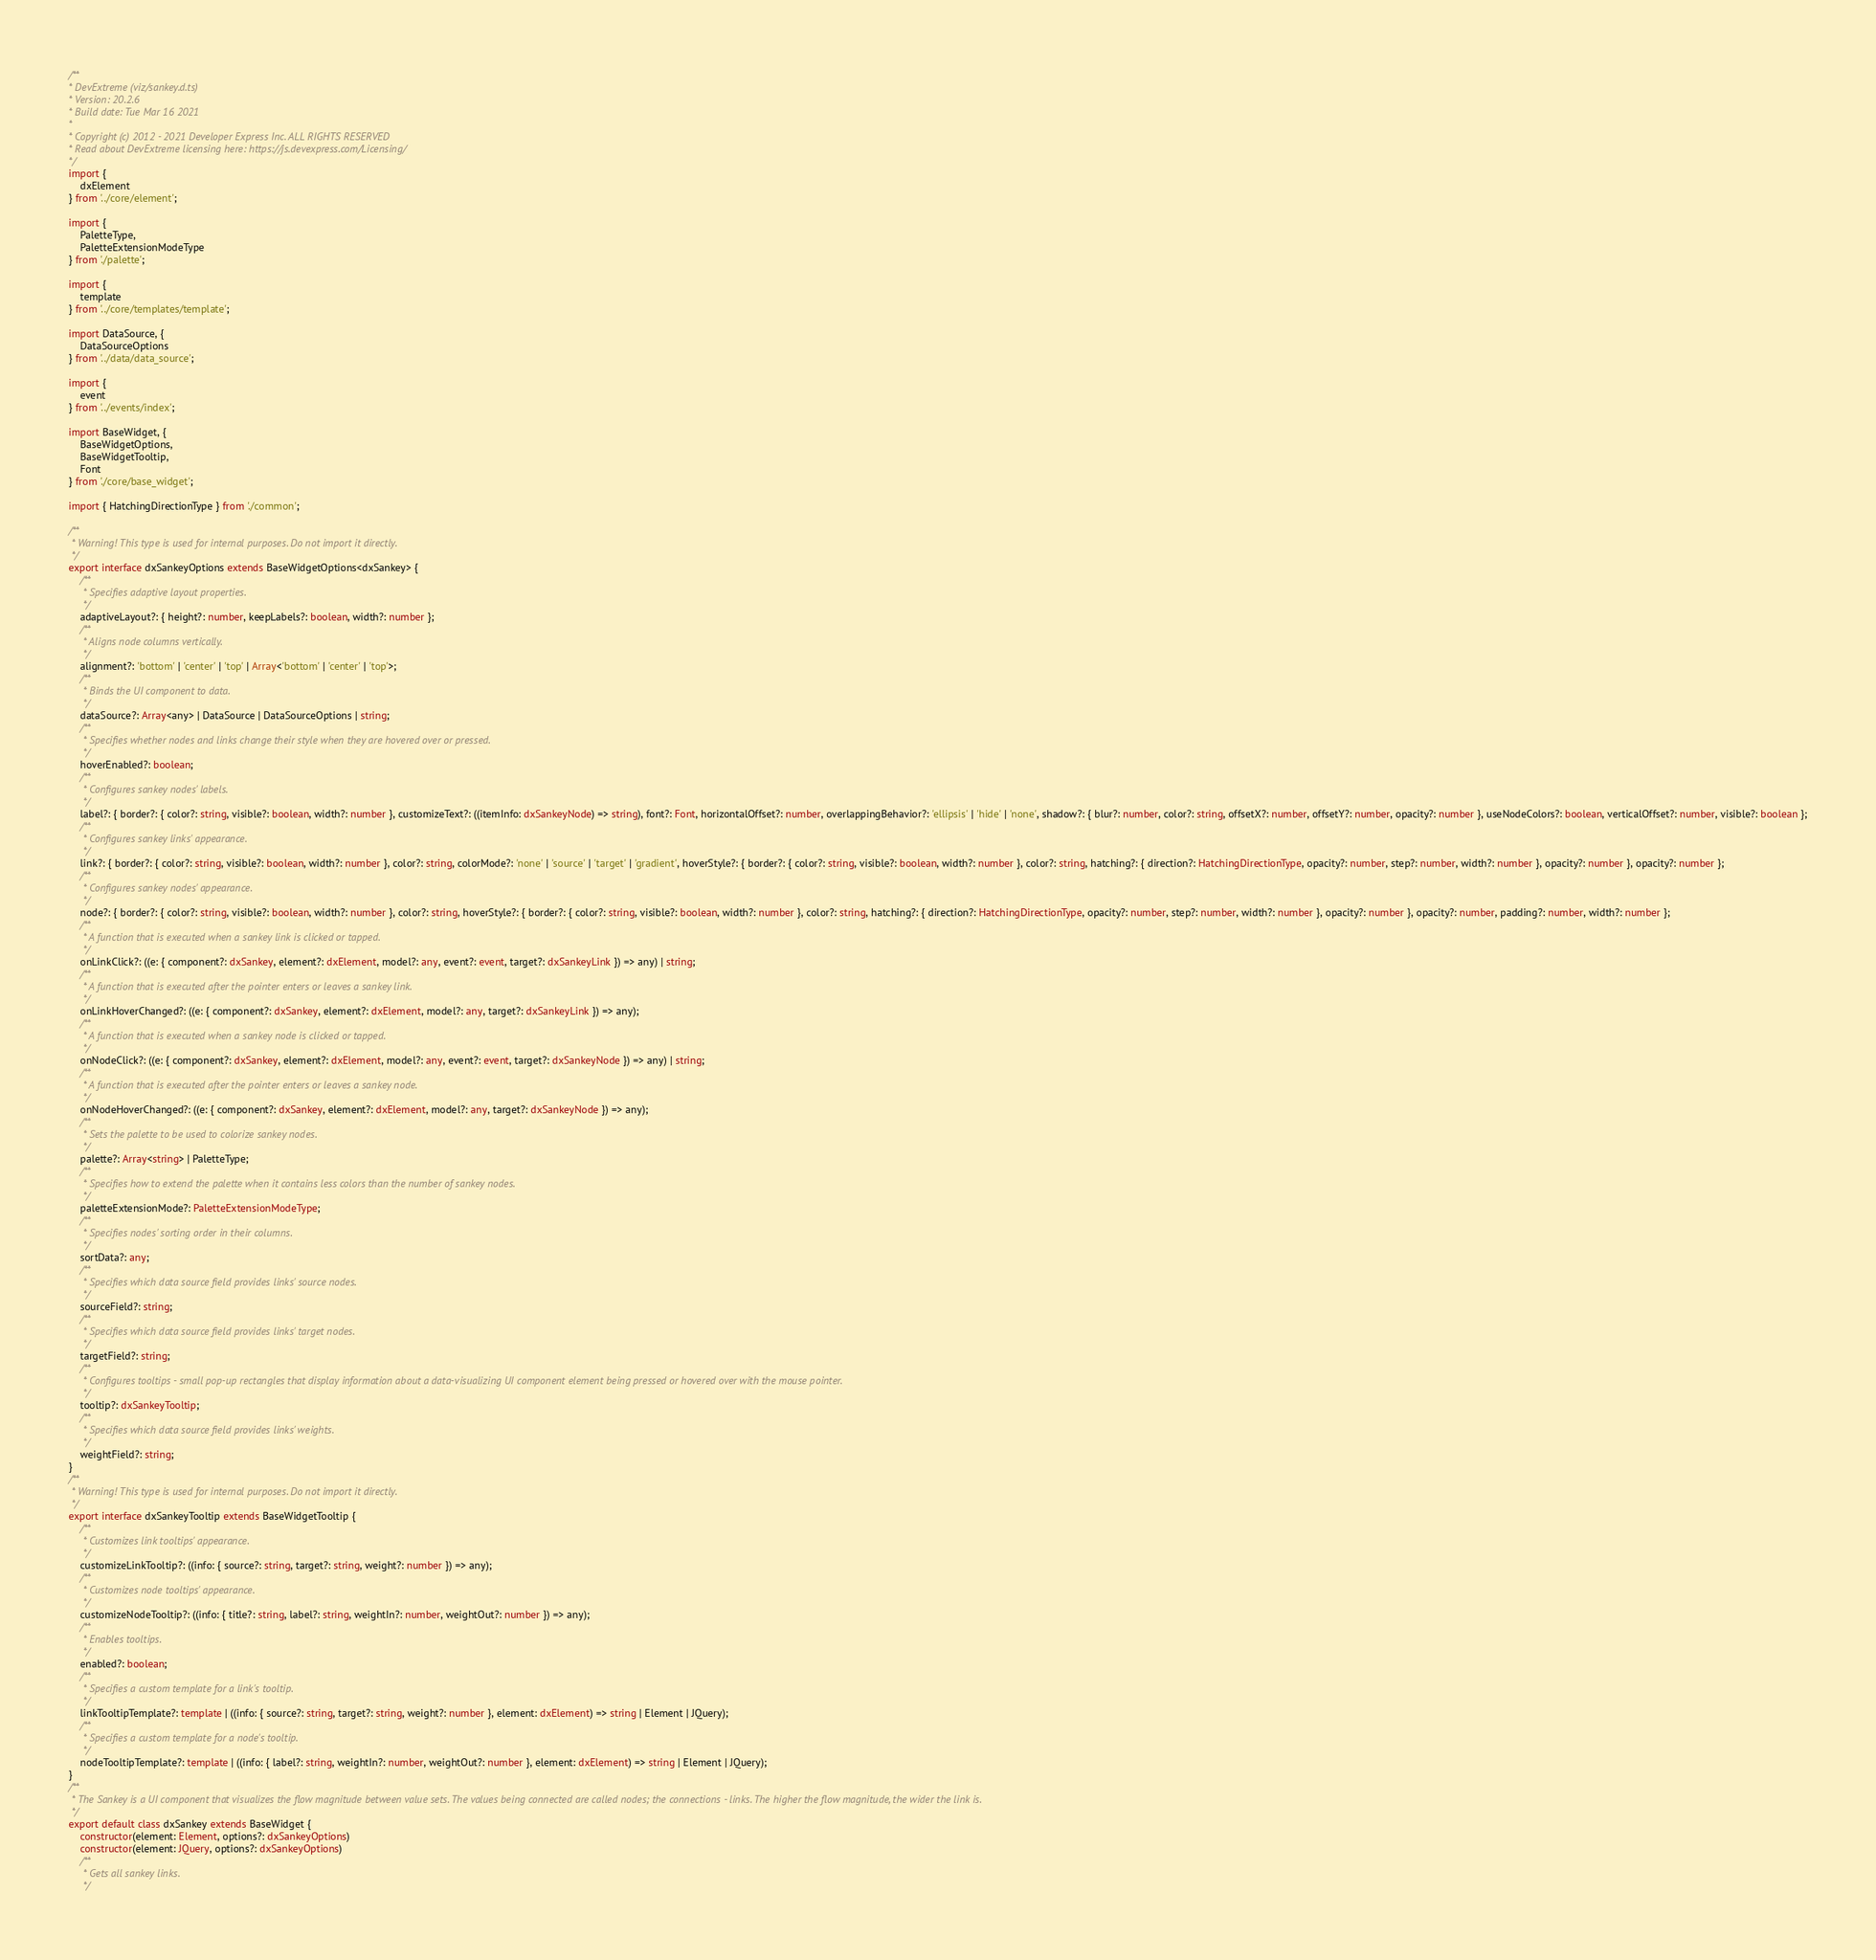Convert code to text. <code><loc_0><loc_0><loc_500><loc_500><_TypeScript_>/**
* DevExtreme (viz/sankey.d.ts)
* Version: 20.2.6
* Build date: Tue Mar 16 2021
*
* Copyright (c) 2012 - 2021 Developer Express Inc. ALL RIGHTS RESERVED
* Read about DevExtreme licensing here: https://js.devexpress.com/Licensing/
*/
import {
    dxElement
} from '../core/element';

import {
    PaletteType,
    PaletteExtensionModeType
} from './palette';

import {
    template
} from '../core/templates/template';

import DataSource, {
    DataSourceOptions
} from '../data/data_source';

import {
    event
} from '../events/index';

import BaseWidget, {
    BaseWidgetOptions,
    BaseWidgetTooltip,
    Font
} from './core/base_widget';

import { HatchingDirectionType } from './common';

/**
 * Warning! This type is used for internal purposes. Do not import it directly.
 */
export interface dxSankeyOptions extends BaseWidgetOptions<dxSankey> {
    /**
     * Specifies adaptive layout properties.
     */
    adaptiveLayout?: { height?: number, keepLabels?: boolean, width?: number };
    /**
     * Aligns node columns vertically.
     */
    alignment?: 'bottom' | 'center' | 'top' | Array<'bottom' | 'center' | 'top'>;
    /**
     * Binds the UI component to data.
     */
    dataSource?: Array<any> | DataSource | DataSourceOptions | string;
    /**
     * Specifies whether nodes and links change their style when they are hovered over or pressed.
     */
    hoverEnabled?: boolean;
    /**
     * Configures sankey nodes' labels.
     */
    label?: { border?: { color?: string, visible?: boolean, width?: number }, customizeText?: ((itemInfo: dxSankeyNode) => string), font?: Font, horizontalOffset?: number, overlappingBehavior?: 'ellipsis' | 'hide' | 'none', shadow?: { blur?: number, color?: string, offsetX?: number, offsetY?: number, opacity?: number }, useNodeColors?: boolean, verticalOffset?: number, visible?: boolean };
    /**
     * Configures sankey links' appearance.
     */
    link?: { border?: { color?: string, visible?: boolean, width?: number }, color?: string, colorMode?: 'none' | 'source' | 'target' | 'gradient', hoverStyle?: { border?: { color?: string, visible?: boolean, width?: number }, color?: string, hatching?: { direction?: HatchingDirectionType, opacity?: number, step?: number, width?: number }, opacity?: number }, opacity?: number };
    /**
     * Configures sankey nodes' appearance.
     */
    node?: { border?: { color?: string, visible?: boolean, width?: number }, color?: string, hoverStyle?: { border?: { color?: string, visible?: boolean, width?: number }, color?: string, hatching?: { direction?: HatchingDirectionType, opacity?: number, step?: number, width?: number }, opacity?: number }, opacity?: number, padding?: number, width?: number };
    /**
     * A function that is executed when a sankey link is clicked or tapped.
     */
    onLinkClick?: ((e: { component?: dxSankey, element?: dxElement, model?: any, event?: event, target?: dxSankeyLink }) => any) | string;
    /**
     * A function that is executed after the pointer enters or leaves a sankey link.
     */
    onLinkHoverChanged?: ((e: { component?: dxSankey, element?: dxElement, model?: any, target?: dxSankeyLink }) => any);
    /**
     * A function that is executed when a sankey node is clicked or tapped.
     */
    onNodeClick?: ((e: { component?: dxSankey, element?: dxElement, model?: any, event?: event, target?: dxSankeyNode }) => any) | string;
    /**
     * A function that is executed after the pointer enters or leaves a sankey node.
     */
    onNodeHoverChanged?: ((e: { component?: dxSankey, element?: dxElement, model?: any, target?: dxSankeyNode }) => any);
    /**
     * Sets the palette to be used to colorize sankey nodes.
     */
    palette?: Array<string> | PaletteType;
    /**
     * Specifies how to extend the palette when it contains less colors than the number of sankey nodes.
     */
    paletteExtensionMode?: PaletteExtensionModeType;
    /**
     * Specifies nodes' sorting order in their columns.
     */
    sortData?: any;
    /**
     * Specifies which data source field provides links' source nodes.
     */
    sourceField?: string;
    /**
     * Specifies which data source field provides links' target nodes.
     */
    targetField?: string;
    /**
     * Configures tooltips - small pop-up rectangles that display information about a data-visualizing UI component element being pressed or hovered over with the mouse pointer.
     */
    tooltip?: dxSankeyTooltip;
    /**
     * Specifies which data source field provides links' weights.
     */
    weightField?: string;
}
/**
 * Warning! This type is used for internal purposes. Do not import it directly.
 */
export interface dxSankeyTooltip extends BaseWidgetTooltip {
    /**
     * Customizes link tooltips' appearance.
     */
    customizeLinkTooltip?: ((info: { source?: string, target?: string, weight?: number }) => any);
    /**
     * Customizes node tooltips' appearance.
     */
    customizeNodeTooltip?: ((info: { title?: string, label?: string, weightIn?: number, weightOut?: number }) => any);
    /**
     * Enables tooltips.
     */
    enabled?: boolean;
    /**
     * Specifies a custom template for a link's tooltip.
     */
    linkTooltipTemplate?: template | ((info: { source?: string, target?: string, weight?: number }, element: dxElement) => string | Element | JQuery);
    /**
     * Specifies a custom template for a node's tooltip.
     */
    nodeTooltipTemplate?: template | ((info: { label?: string, weightIn?: number, weightOut?: number }, element: dxElement) => string | Element | JQuery);
}
/**
 * The Sankey is a UI component that visualizes the flow magnitude between value sets. The values being connected are called nodes; the connections - links. The higher the flow magnitude, the wider the link is.
 */
export default class dxSankey extends BaseWidget {
    constructor(element: Element, options?: dxSankeyOptions)
    constructor(element: JQuery, options?: dxSankeyOptions)
    /**
     * Gets all sankey links.
     */</code> 